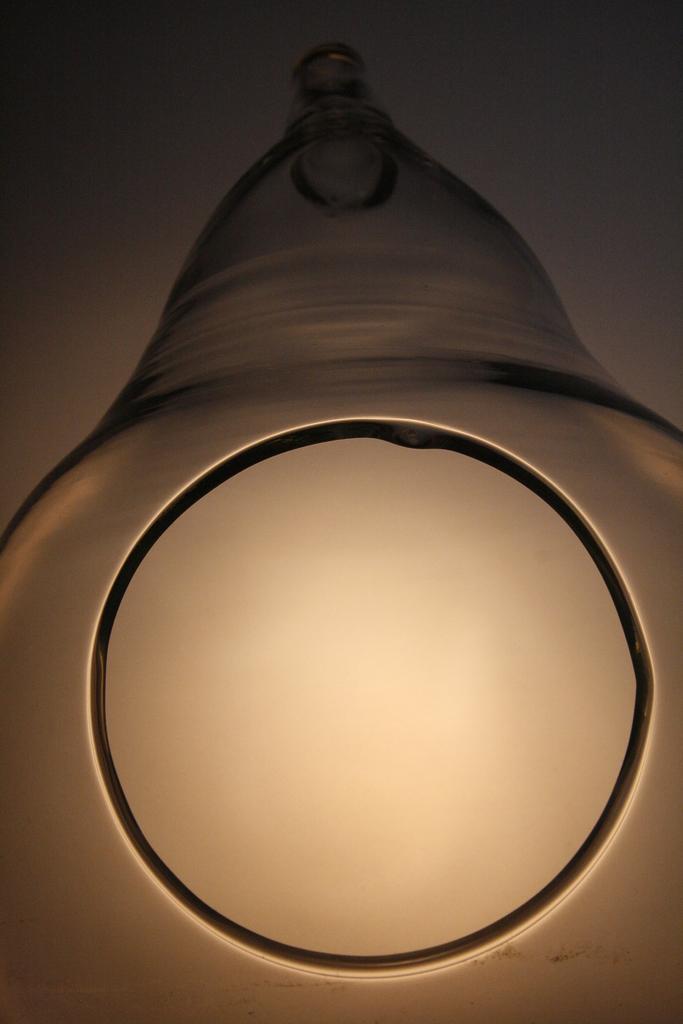Please provide a concise description of this image. In this picture there is a light which is in circle shape and there is an object above it. 